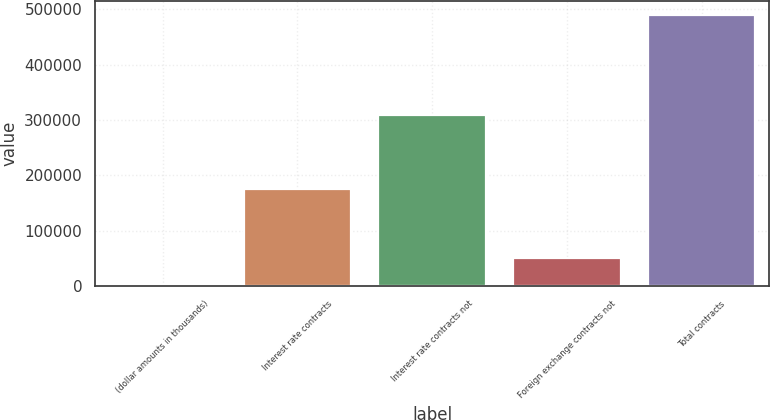Convert chart to OTSL. <chart><loc_0><loc_0><loc_500><loc_500><bar_chart><fcel>(dollar amounts in thousands)<fcel>Interest rate contracts<fcel>Interest rate contracts not<fcel>Foreign exchange contracts not<fcel>Total contracts<nl><fcel>2011<fcel>175932<fcel>309496<fcel>50841.2<fcel>490313<nl></chart> 